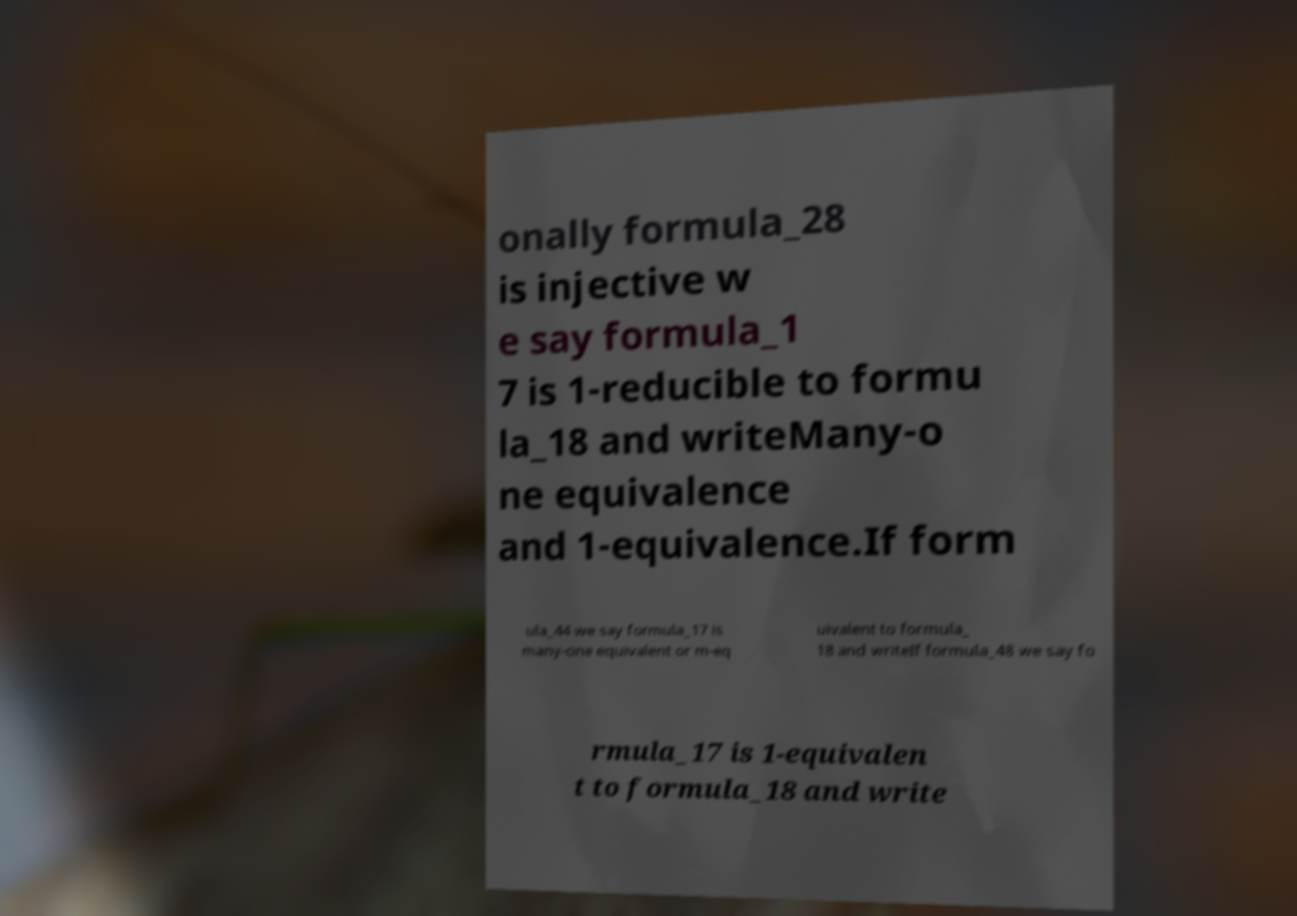For documentation purposes, I need the text within this image transcribed. Could you provide that? onally formula_28 is injective w e say formula_1 7 is 1-reducible to formu la_18 and writeMany-o ne equivalence and 1-equivalence.If form ula_44 we say formula_17 is many-one equivalent or m-eq uivalent to formula_ 18 and writeIf formula_48 we say fo rmula_17 is 1-equivalen t to formula_18 and write 